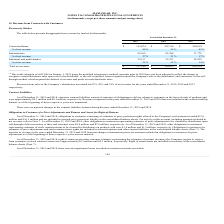According to Maxlinear's financial document, After using the modified retrospective method, amounts prior to which year have not been adjusted? According to the financial document, 2018. The relevant text states: "2019 2018 2017 (1) 2019 2018 2017 (1)..." Also, What was the revenue from sales to the Company's distributors from 2019, 2018 and 2017 respectively? The document contains multiple relevant values: 52%, 42%, 34%. From the document: "s to the Company’s distributors accounted for 52%, 42% and 34% of net revenue for the years ended December 31, 2019, 2018 and 2017, Company’s distribu..." Also, What was the Connected home revenue in 2019? According to the financial document, $152,674 (in thousands). The relevant text states: "Connected home $ 152,674 $ 207,336 $ 288,610..." Also, can you calculate: What was the change in Connected home from 2018 to 2019? Based on the calculation: 152,674 - 207,336, the result is -54662 (in thousands). This is based on the information: "Connected home $ 152,674 $ 207,336 $ 288,610 Connected home $ 152,674 $ 207,336 $ 288,610..." The key data points involved are: 152,674, 207,336. Also, can you calculate: What was the average Infrastructure between 2017-2019? To answer this question, I need to perform calculations using the financial data. The calculation is: (85,369 + 82,388 + 71,779) / 3, which equals 79845.33 (in thousands). This is based on the information: "Infrastructure 85,369 82,388 71,779 Infrastructure 85,369 82,388 71,779 Infrastructure 85,369 82,388 71,779..." The key data points involved are: 71,779, 82,388, 85,369. Additionally, In which year was Total net revenue less than 400,000 thousands? The document shows two values: 2019 and 2018. Locate and analyze total net revenue in row 9. From the document: "2019 2018 2017 (1) 2019 2018 2017 (1)..." 